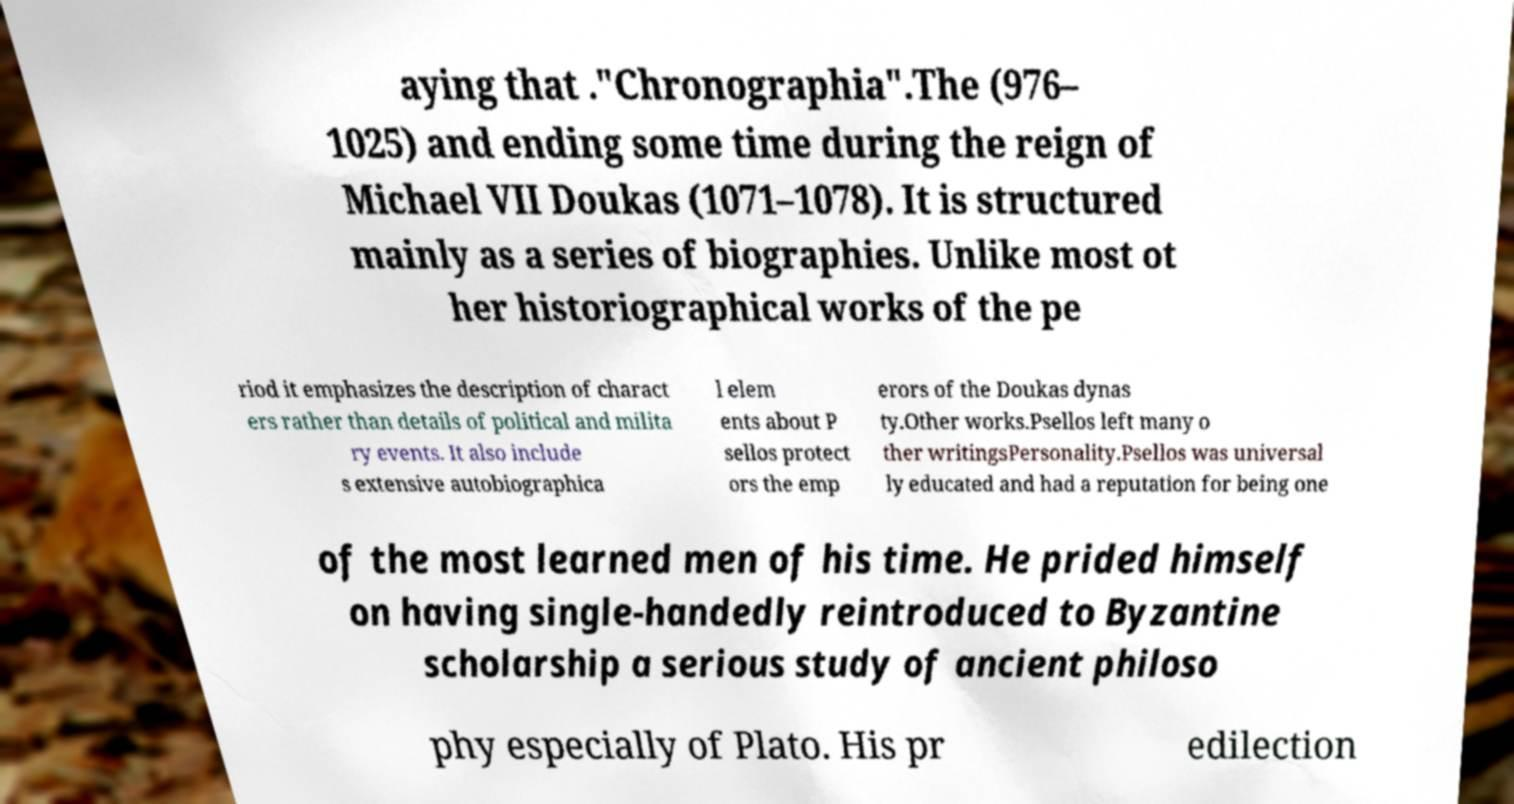For documentation purposes, I need the text within this image transcribed. Could you provide that? aying that ."Chronographia".The (976– 1025) and ending some time during the reign of Michael VII Doukas (1071–1078). It is structured mainly as a series of biographies. Unlike most ot her historiographical works of the pe riod it emphasizes the description of charact ers rather than details of political and milita ry events. It also include s extensive autobiographica l elem ents about P sellos protect ors the emp erors of the Doukas dynas ty.Other works.Psellos left many o ther writingsPersonality.Psellos was universal ly educated and had a reputation for being one of the most learned men of his time. He prided himself on having single-handedly reintroduced to Byzantine scholarship a serious study of ancient philoso phy especially of Plato. His pr edilection 